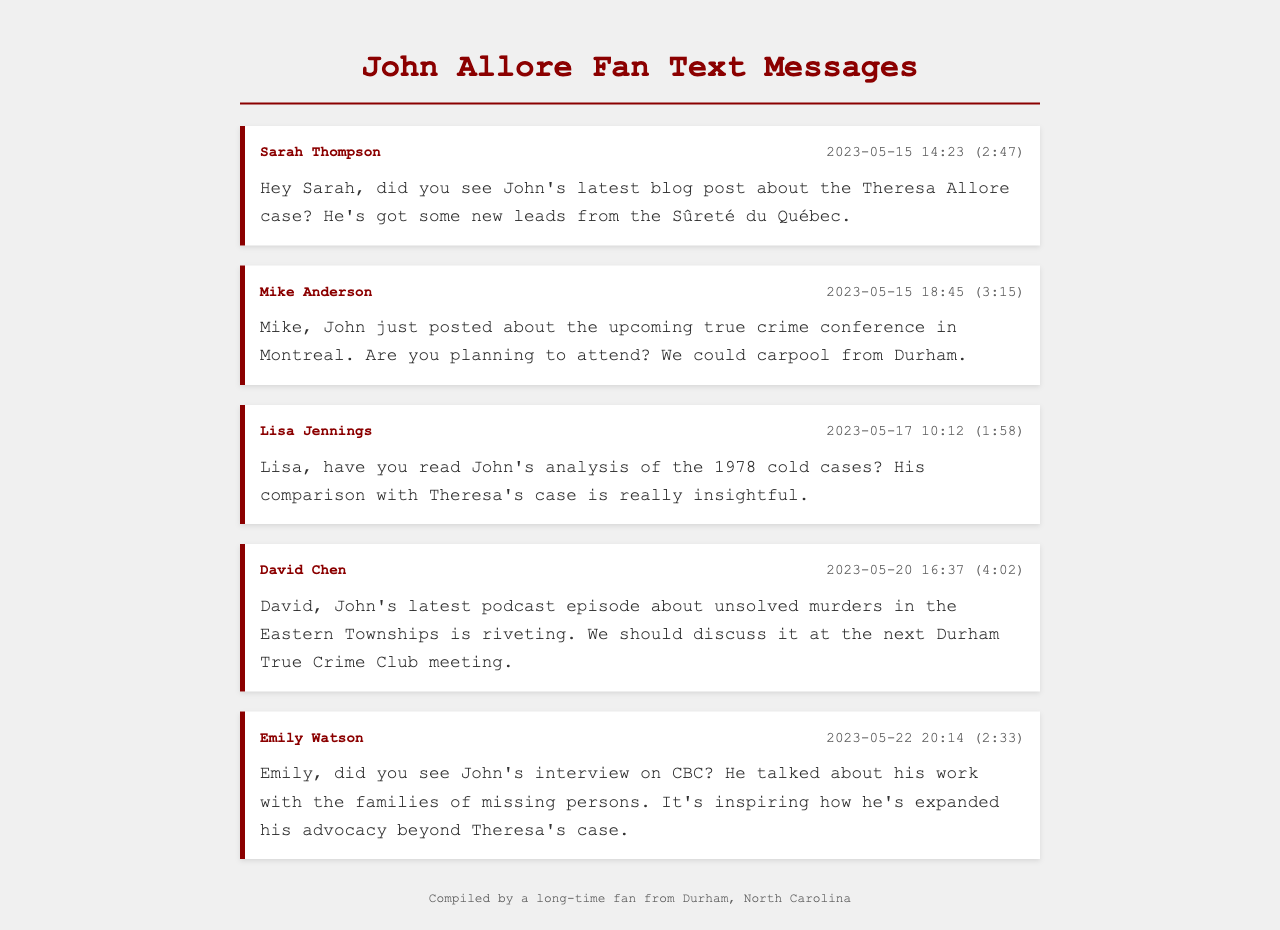What is the date of Sarah's message? Sarah's message is dated 2023-05-15, as specified in the message header.
Answer: 2023-05-15 Who discussed John's latest podcast episode? The message from David Chen mentions discussing John's latest podcast episode about unsolved murders.
Answer: David Chen What time was Lisa Jennings' message sent? Lisa Jennings’ message was sent at 10:12 according to the message details.
Answer: 10:12 Which case does John Allore's latest blog post focus on? The first message mentions that John's latest blog post is about the Theresa Allore case.
Answer: Theresa Allore case Who mentioned the upcoming true crime conference? Mike Anderson refers to the true crime conference in his message, asking if the recipient plans to attend.
Answer: Mike Anderson What is the color used for message headers? The message headers use a shade of dark red (#8b0000) as indicated by the styling of the text.
Answer: Dark red How many people are mentioned in the text messages? The document includes messages from five different individuals: Sarah, Mike, Lisa, David, and Emily.
Answer: Five In which city is the true crime club meeting mentioned? David mentions discussing John's podcast episode at the Durham True Crime Club meeting in his message.
Answer: Durham What is the primary topic in Emily Watson's message? Emily's message discusses John's interview on CBC and his advocacy work related to missing persons.
Answer: Advocacy work 